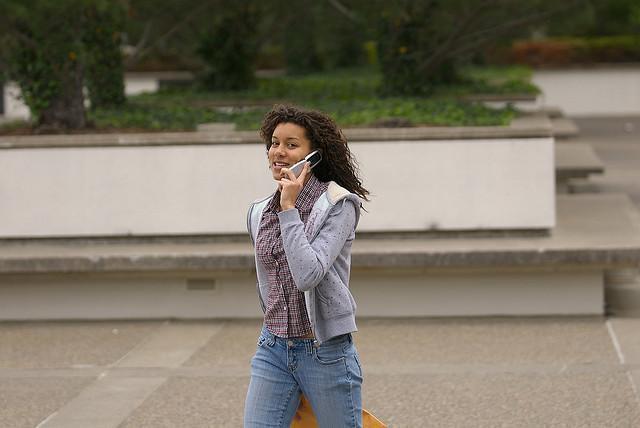How would she close the front of her sweater?
Indicate the correct choice and explain in the format: 'Answer: answer
Rationale: rationale.'
Options: Zipper, strings, velcro, buttons. Answer: zipper.
Rationale: The front of her sweater is visible and has a zipper on the edge. zippers are used for fastening so a garment with a zipper in this placement on either side would be fastened by the zipper. 